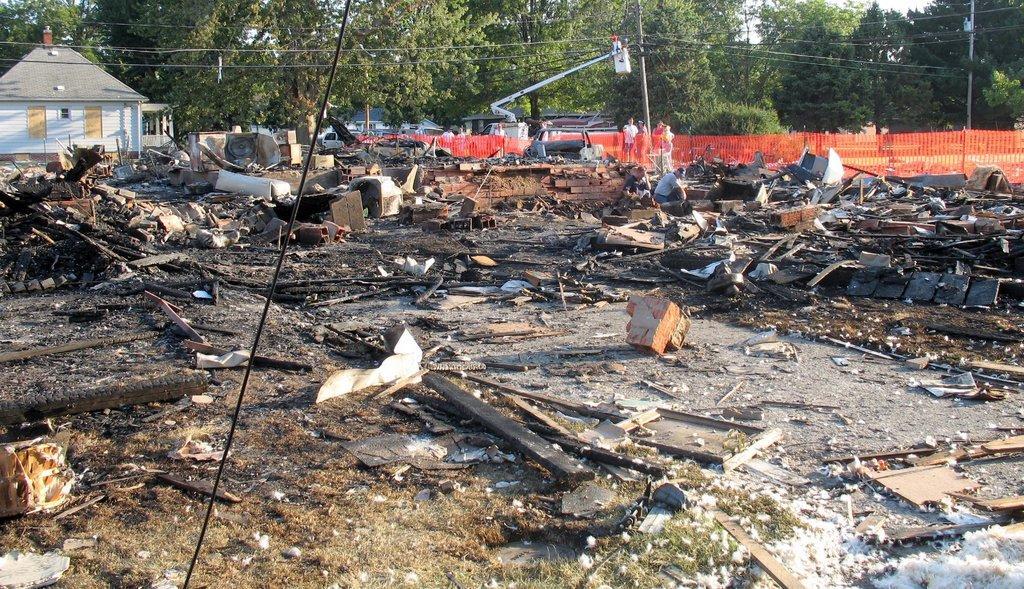In one or two sentences, can you explain what this image depicts? In this image there are trees truncated towards the top of the image, there is a house truncated towards the left of the image, there are persons standing, there are wires truncated, there are poles truncated towards the top of the image, there is a fencing truncated towards the right of the image, there is a vehicle, there are objects on the ground, there are objects truncated towards the left of the image, there are objects truncated towards the right of the image, there is grass truncated towards the bottom of the image, there are objects truncated towards the bottom of the image. 